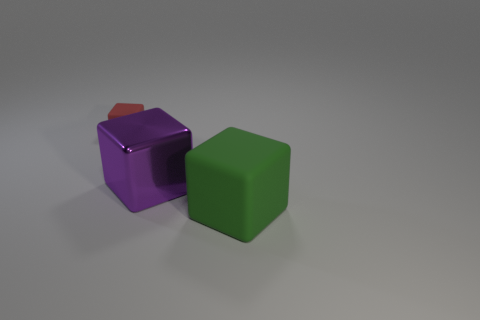Is there a large purple shiny thing behind the matte object that is behind the big green rubber cube?
Your response must be concise. No. How many shiny cubes have the same color as the big rubber cube?
Provide a succinct answer. 0. Do the purple cube and the green object have the same material?
Provide a succinct answer. No. Are there any big green matte blocks in front of the metallic object?
Ensure brevity in your answer.  Yes. The large green cube in front of the big object that is behind the green cube is made of what material?
Your answer should be compact. Rubber. What is the size of the purple metallic thing that is the same shape as the red object?
Offer a very short reply. Large. Is the color of the metallic thing the same as the tiny rubber thing?
Offer a very short reply. No. There is a block that is in front of the red object and on the left side of the green matte thing; what is its color?
Keep it short and to the point. Purple. Do the matte cube that is in front of the red matte thing and the red object have the same size?
Give a very brief answer. No. Are there any other things that are the same shape as the red object?
Offer a very short reply. Yes. 